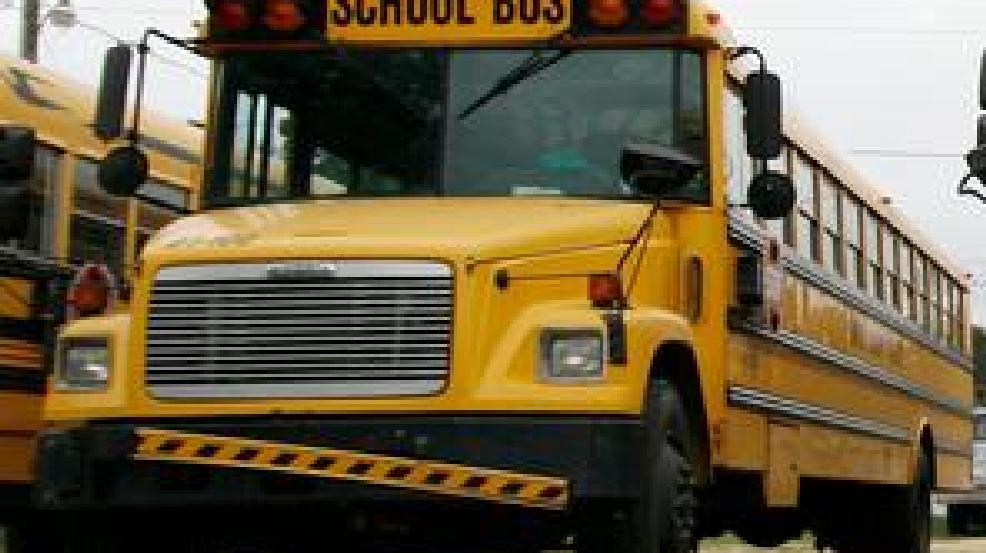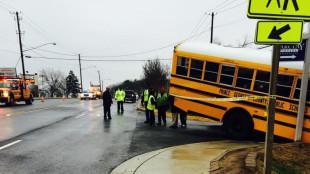The first image is the image on the left, the second image is the image on the right. Analyze the images presented: Is the assertion "The door of the bus in the image on the left has its door open." valid? Answer yes or no. No. The first image is the image on the left, the second image is the image on the right. Assess this claim about the two images: "There is no apparent damage to the bus in the image on the right.". Correct or not? Answer yes or no. No. 